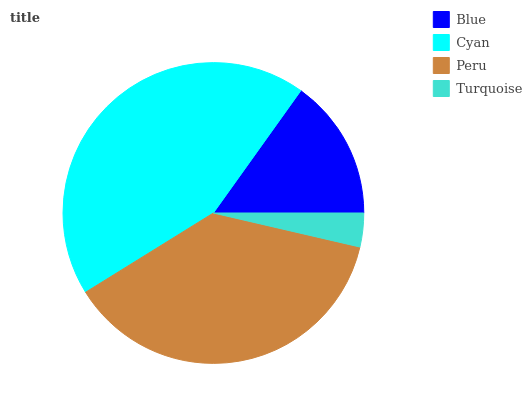Is Turquoise the minimum?
Answer yes or no. Yes. Is Cyan the maximum?
Answer yes or no. Yes. Is Peru the minimum?
Answer yes or no. No. Is Peru the maximum?
Answer yes or no. No. Is Cyan greater than Peru?
Answer yes or no. Yes. Is Peru less than Cyan?
Answer yes or no. Yes. Is Peru greater than Cyan?
Answer yes or no. No. Is Cyan less than Peru?
Answer yes or no. No. Is Peru the high median?
Answer yes or no. Yes. Is Blue the low median?
Answer yes or no. Yes. Is Cyan the high median?
Answer yes or no. No. Is Turquoise the low median?
Answer yes or no. No. 